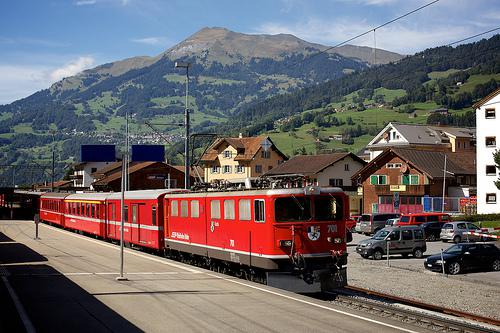Question: how many passenger train cars are there?
Choices:
A. 2.
B. 4.
C. 3.
D. 5.
Answer with the letter. Answer: C Question: where is the train number?
Choices:
A. Front.
B. Back.
C. Front left side of engine.
D. Side.
Answer with the letter. Answer: C Question: what type of train is it?
Choices:
A. Battery.
B. Broken.
C. Steam powered.
D. Electric.
Answer with the letter. Answer: D Question: what kind of landscape is it?
Choices:
A. Ocean.
B. Hills-mountains.
C. Forest.
D. City buildings.
Answer with the letter. Answer: B 